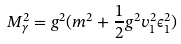<formula> <loc_0><loc_0><loc_500><loc_500>M _ { \gamma } ^ { 2 } = g ^ { 2 } ( m ^ { 2 } + { \frac { 1 } { 2 } } g ^ { 2 } v _ { 1 } ^ { 2 } \epsilon _ { 1 } ^ { 2 } )</formula> 